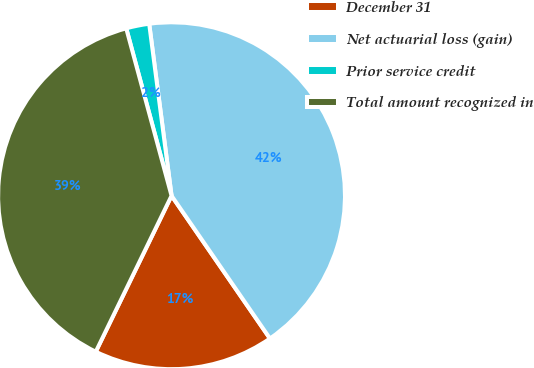Convert chart to OTSL. <chart><loc_0><loc_0><loc_500><loc_500><pie_chart><fcel>December 31<fcel>Net actuarial loss (gain)<fcel>Prior service credit<fcel>Total amount recognized in<nl><fcel>16.8%<fcel>42.45%<fcel>2.15%<fcel>38.59%<nl></chart> 